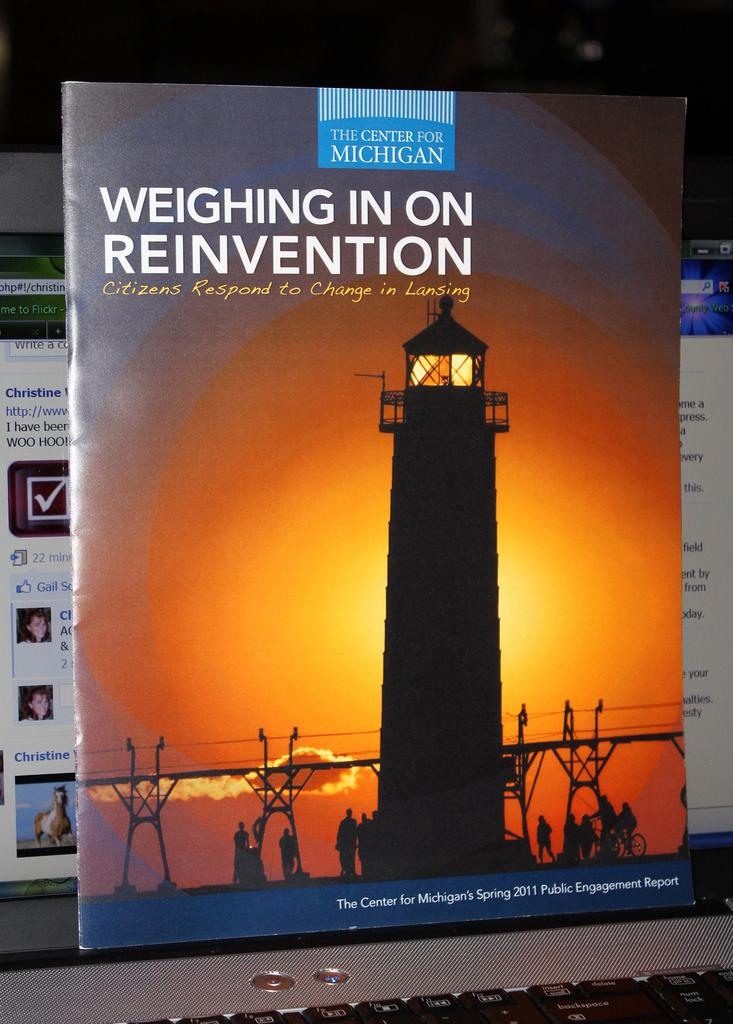<image>
Summarize the visual content of the image. The Center for Michigan is shown on this advert flyer. 